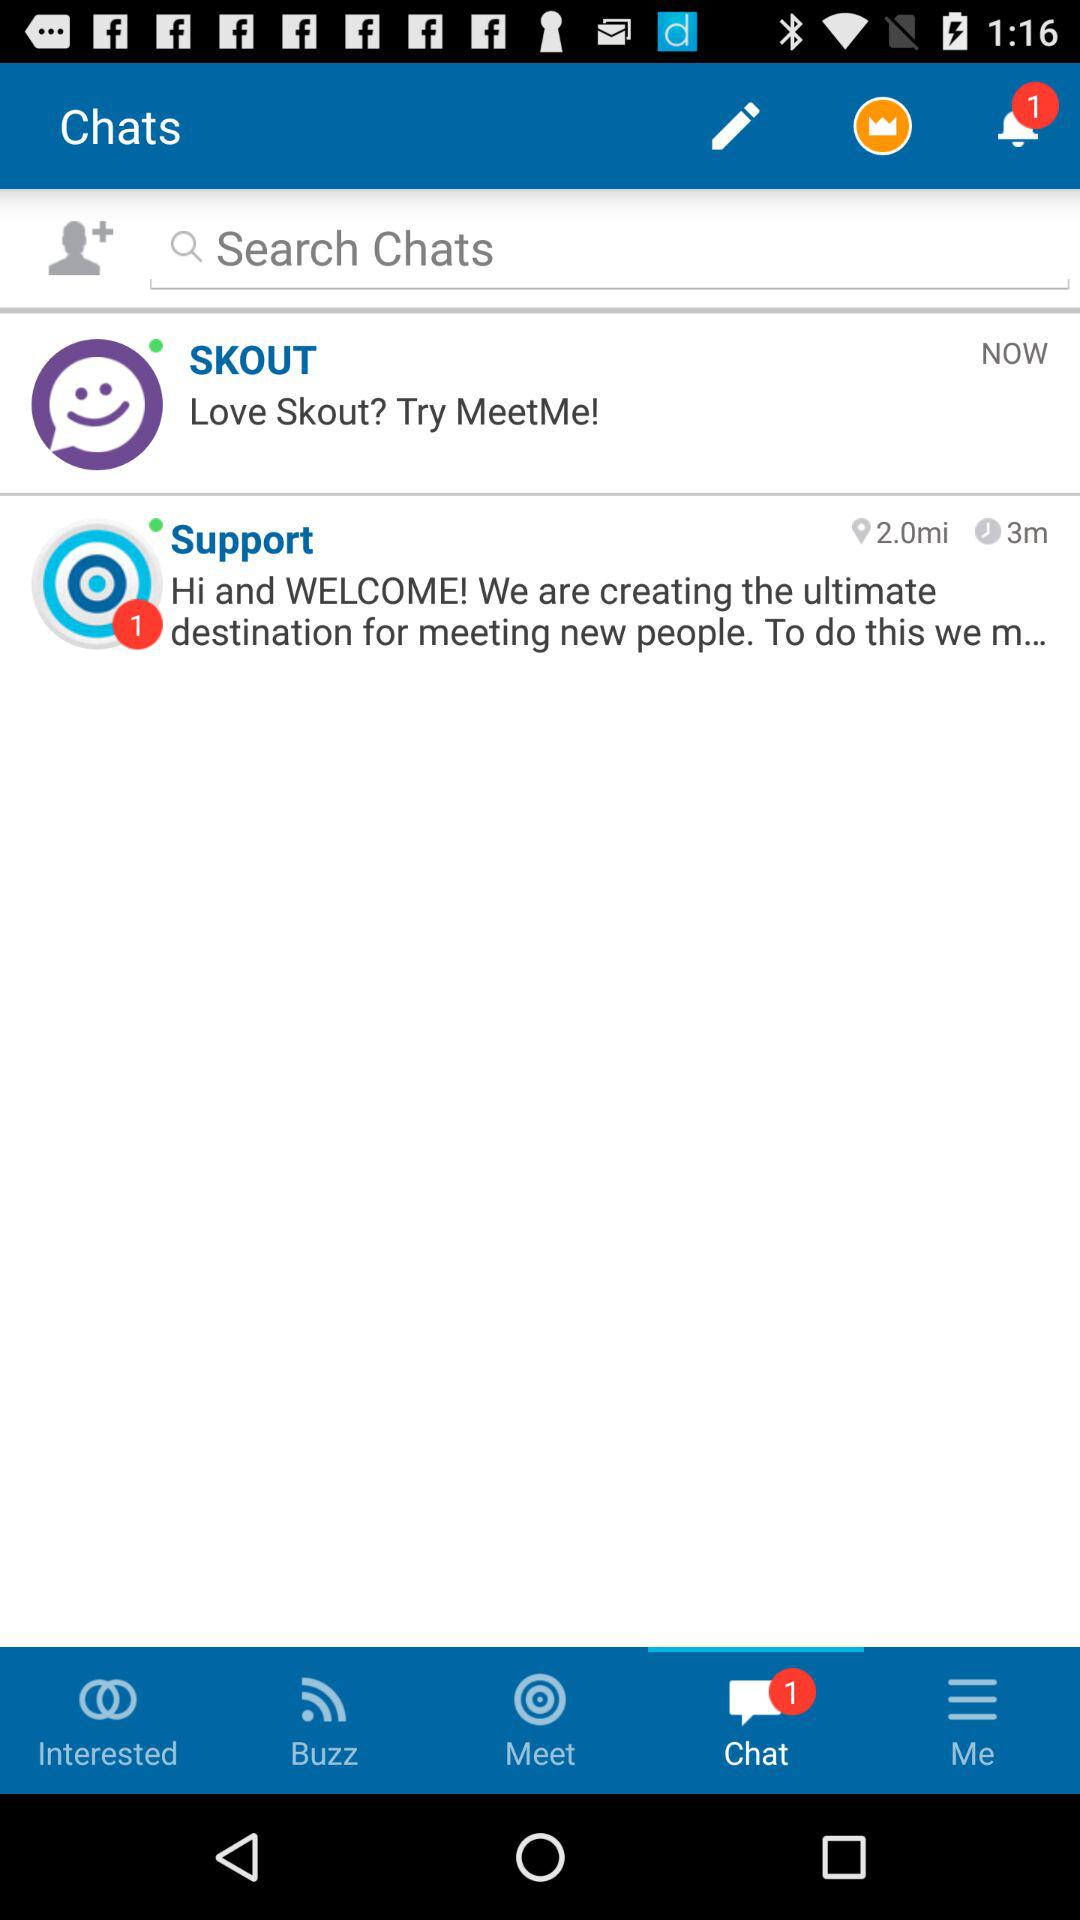The new chats are there for which users?
When the provided information is insufficient, respond with <no answer>. <no answer> 